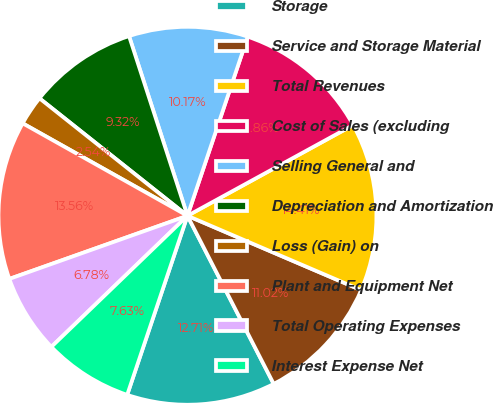Convert chart. <chart><loc_0><loc_0><loc_500><loc_500><pie_chart><fcel>Storage<fcel>Service and Storage Material<fcel>Total Revenues<fcel>Cost of Sales (excluding<fcel>Selling General and<fcel>Depreciation and Amortization<fcel>Loss (Gain) on<fcel>Plant and Equipment Net<fcel>Total Operating Expenses<fcel>Interest Expense Net<nl><fcel>12.71%<fcel>11.02%<fcel>14.41%<fcel>11.86%<fcel>10.17%<fcel>9.32%<fcel>2.54%<fcel>13.56%<fcel>6.78%<fcel>7.63%<nl></chart> 